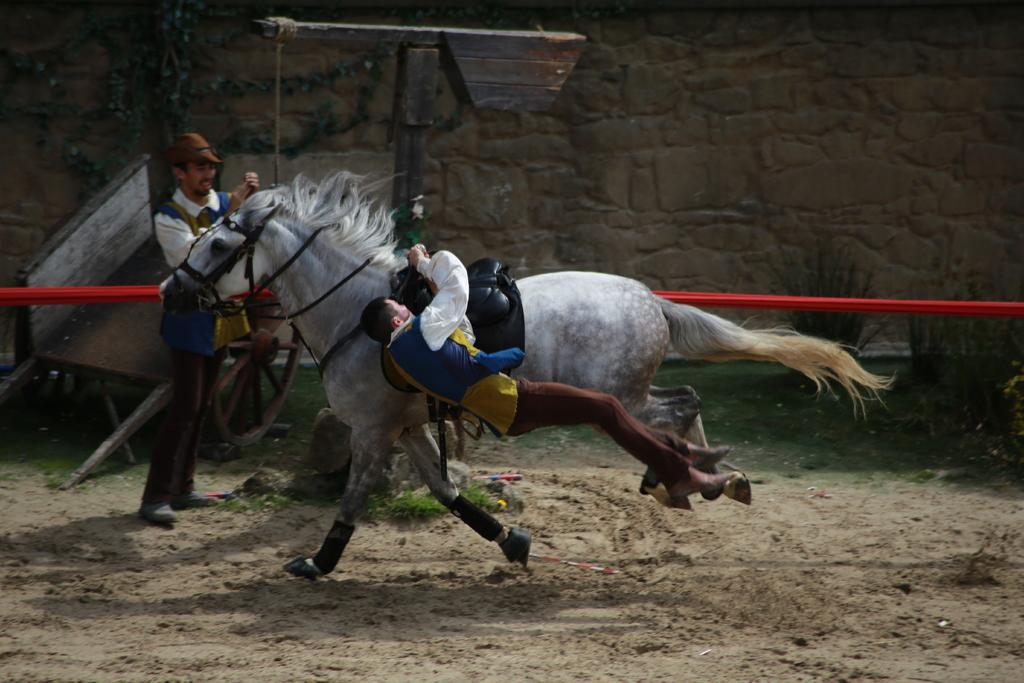What is the person in the air doing? The person in the air is holding a belt that is attached to a horse. What is the person on the ground doing? The person on the ground is not mentioned in the facts, so we cannot determine their actions. What can be seen in the background of the image? In the background of the image, there is a cart, plants, and a wall. What is the purpose of the belt in the image? The belt is used to connect the person in the air to the horse. Where is the lunchroom located in the image? There is no mention of a lunchroom in the image or the provided facts. What committee is responsible for the horse and cart in the image? There is no mention of a committee or any organizational structure in the image or the provided facts. 